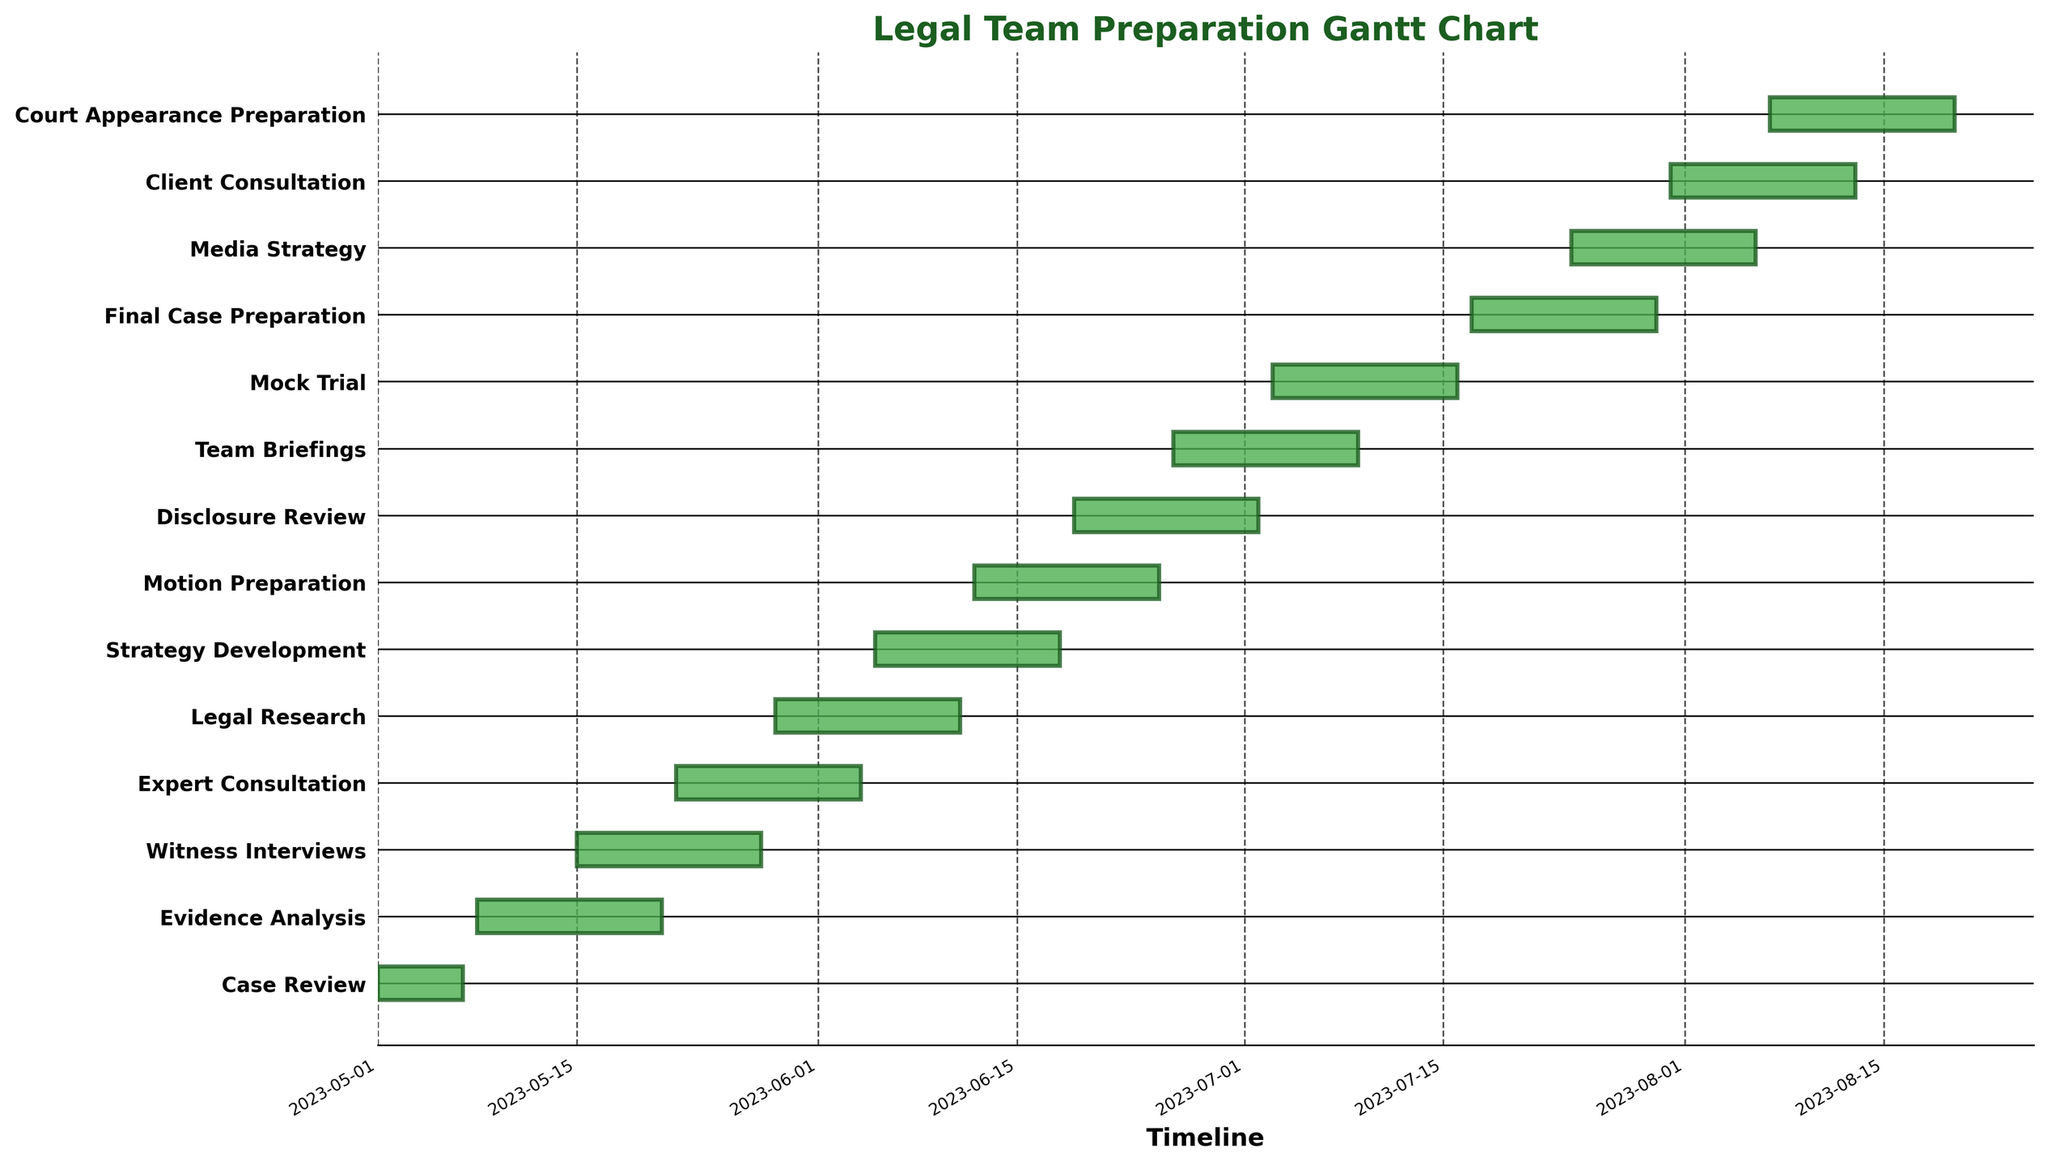What's the title of the Gantt chart? The title of the Gantt chart is clearly stated at the top of the figure.
Answer: Legal Team Preparation Gantt Chart Which task starts first in the timeline? The start date of the tasks can be observed on the x-axis. The task with the earliest start date is the first one to begin.
Answer: Case Review How many days does the 'Mock Trial' task last? The duration of each task is derived from the start and end dates. By calculating the number of days between the start and end date for 'Mock Trial,' we get its duration.
Answer: 14 days Which tasks are overlapping with 'Evidence Analysis'? By aligning the start and end dates of 'Evidence Analysis' with other tasks on the Gantt chart, we can identify which tasks show an overlapping period.
Answer: Witness Interviews What is the total duration of 'Strategy Development' and 'Motion Preparation' combined? The duration of each task is given in days. Adding up the durations of 'Strategy Development' and 'Motion Preparation' will give the combined duration.
Answer: 28 days Which task has the longest duration within the first half of the timeline? By reviewing the durations and dividing the timeline in half, one can determine which task has the longest duration within the initial period.
Answer: Evidence Analysis (14 days) How many tasks are scheduled to start in June 2023? By examining the Gantt chart for tasks with start dates in June 2023, we can count the number of such tasks.
Answer: 5 tasks Which tasks are scheduled to end after July 31, 2023? Checking the end dates of the tasks against the specified date allows us to see which tasks conclude after July 31, 2023.
Answer: Client Consultation, Court Appearance Preparation Is there any task that ends before the 'Mock Trial' starts? The end date of each task can be compared with the start date of 'Mock Trial' to determine if any task ends before 'Mock Trial' begins.
Answer: Final Case Preparation When does the 'Final Case Preparation' task start and end? The start and end dates are directly available for each task on the Gantt chart.
Answer: July 17, 2023 - July 30, 2023 